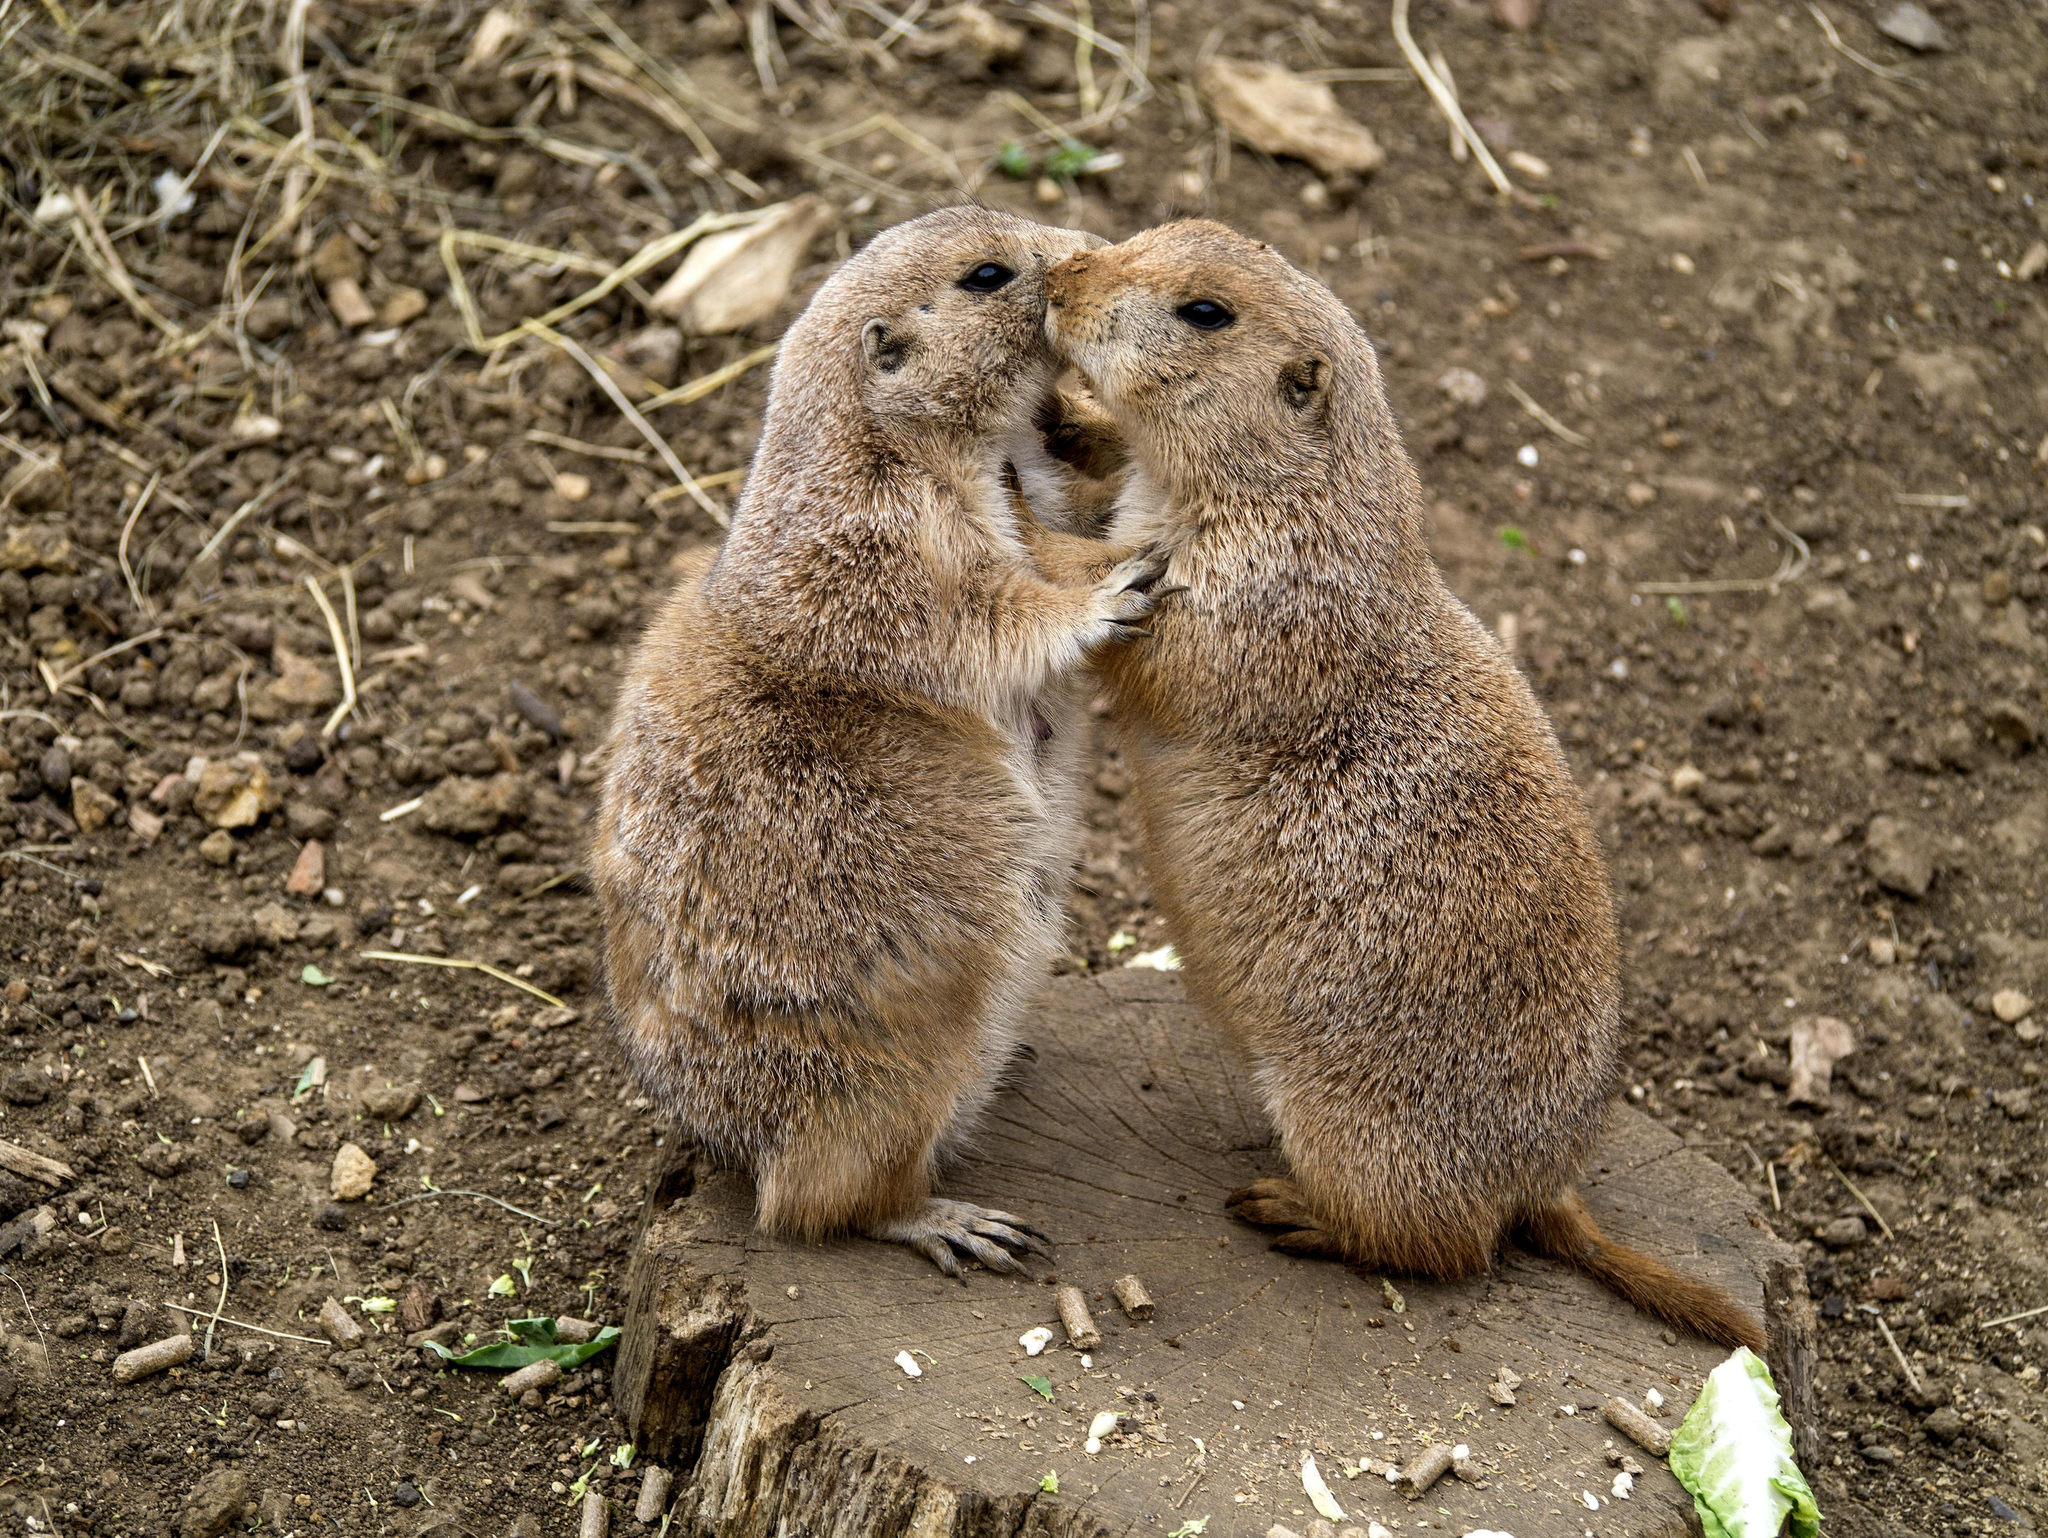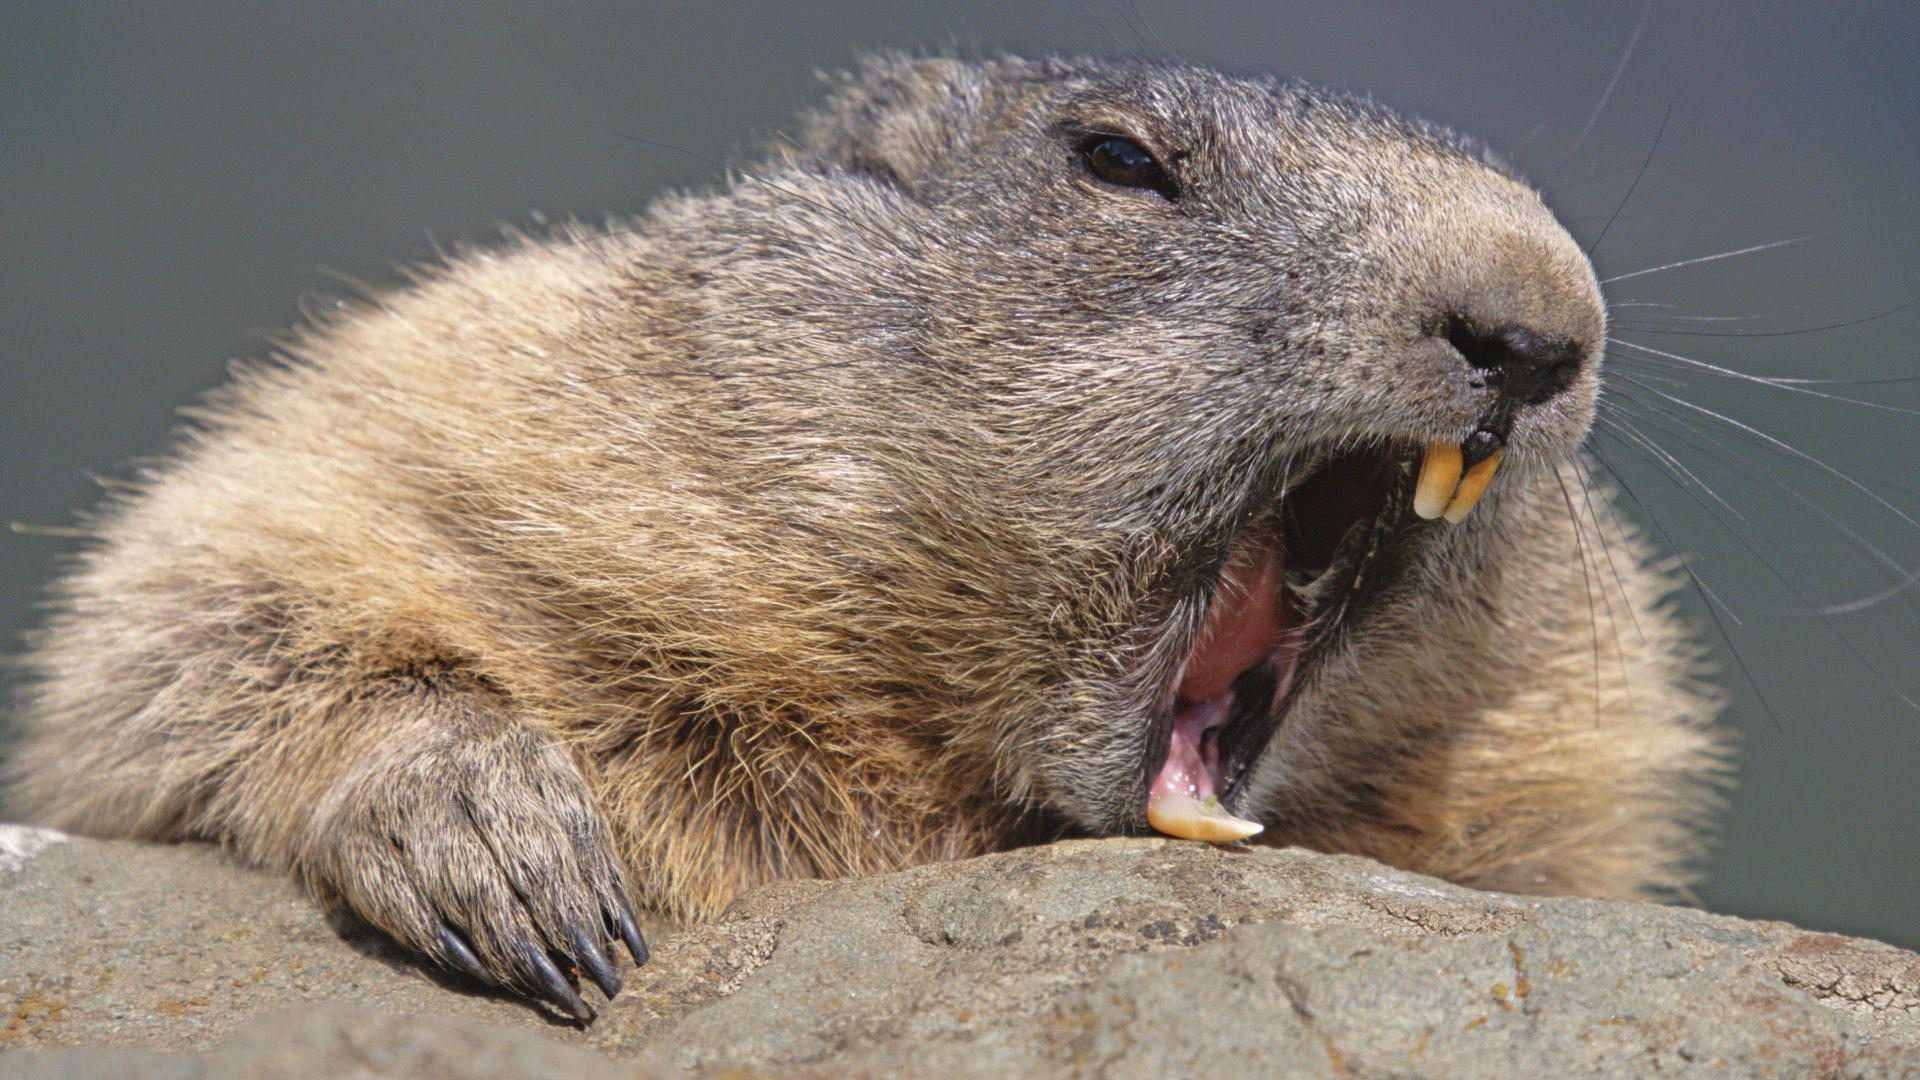The first image is the image on the left, the second image is the image on the right. For the images shown, is this caption "There are two marmots total." true? Answer yes or no. No. The first image is the image on the left, the second image is the image on the right. Given the left and right images, does the statement "One image includes multiple marmots that are standing on their hind legs and have their front paws raised." hold true? Answer yes or no. Yes. 